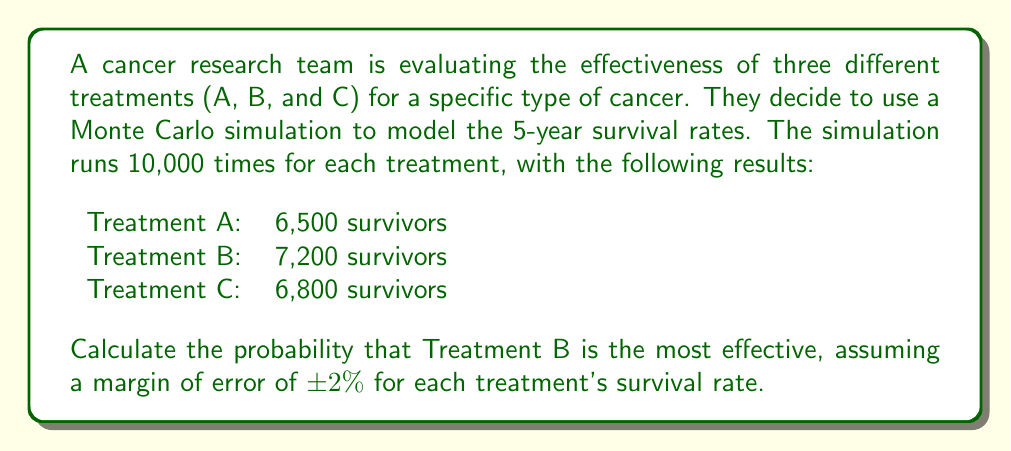What is the answer to this math problem? To solve this problem, we'll follow these steps:

1) First, calculate the survival rates for each treatment:

   Treatment A: $\frac{6500}{10000} = 0.65$ or $65\%$
   Treatment B: $\frac{7200}{10000} = 0.72$ or $72\%$
   Treatment C: $\frac{6800}{10000} = 0.68$ or $68\%$

2) Consider the margin of error of $\pm 2\%$. This means each treatment's true survival rate could be up to 2% higher or lower than the simulated rate.

3) For Treatment B to be the most effective, it needs to maintain its lead even if:
   - Treatment B's rate is at its lower bound (70%)
   - Both other treatments are at their upper bounds (67% for A, 70% for C)

4) The probability of this scenario can be calculated using the normal distribution. We'll use the standard error (SE) for a proportion:

   $SE = \sqrt{\frac{p(1-p)}{n}}$

   where $p$ is the proportion and $n$ is the sample size.

5) For Treatment B:
   $SE_B = \sqrt{\frac{0.72(1-0.72)}{10000}} = 0.00448$

6) The z-score for the lower bound of Treatment B is:

   $z = \frac{0.70 - 0.72}{0.00448} = -4.46$

7) The probability that Treatment B's true rate is above 70% is:

   $P(B > 0.70) = 1 - \Phi(-4.46) \approx 0.9999996$

   where $\Phi$ is the cumulative distribution function of the standard normal distribution.

8) Similarly calculate for Treatments A and C to be below 70%:

   $SE_A = \sqrt{\frac{0.65(1-0.65)}{10000}} = 0.00477$
   $z_A = \frac{0.70 - 0.65}{0.00477} = 10.48$
   $P(A < 0.70) = \Phi(10.48) \approx 1$

   $SE_C = \sqrt{\frac{0.68(1-0.68)}{10000}} = 0.00466$
   $z_C = \frac{0.70 - 0.68}{0.00466} = 4.29$
   $P(C < 0.70) = \Phi(4.29) \approx 0.9999911$

9) The probability that all these conditions are met simultaneously is the product of these individual probabilities:

   $P(\text{B is most effective}) = 0.9999996 \times 1 \times 0.9999911 \approx 0.9999907$
Answer: $0.9999907$ or approximately $99.99907\%$ 